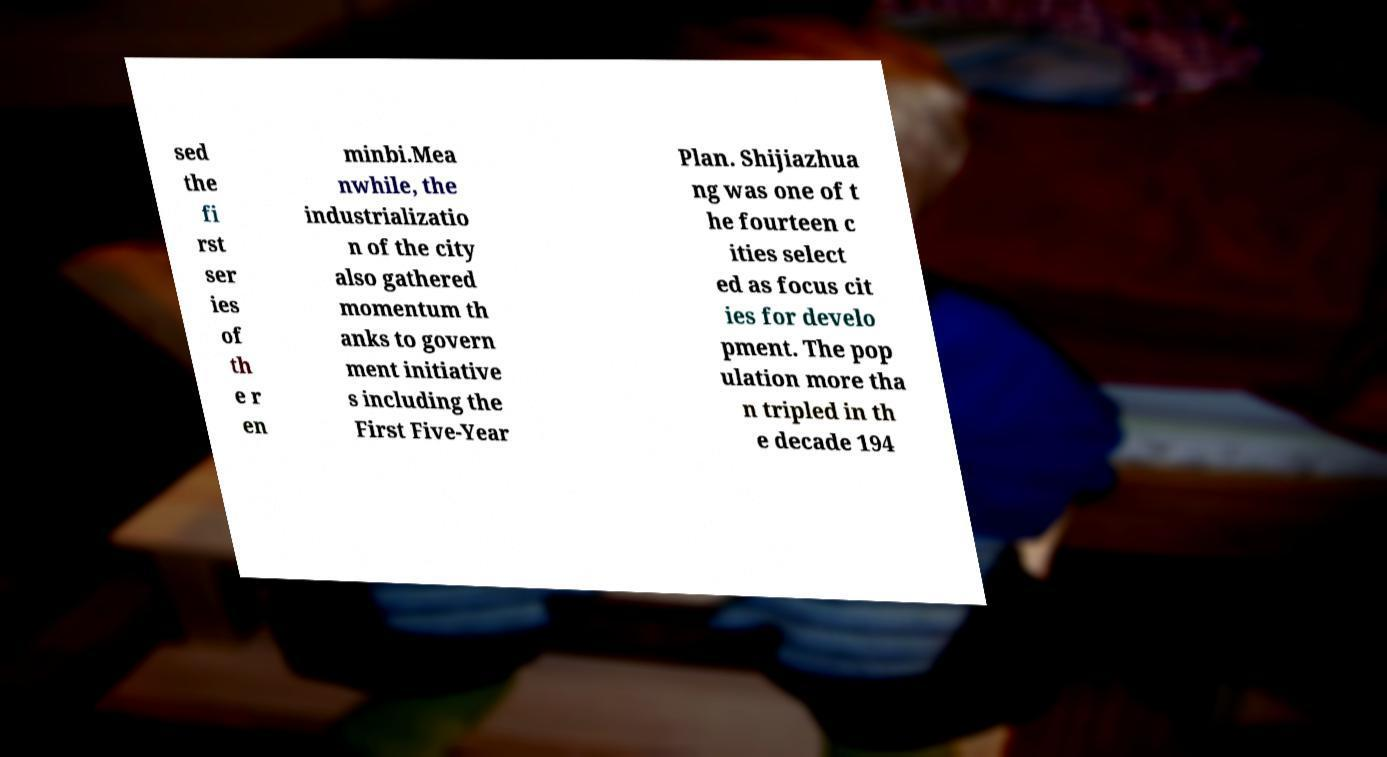Please read and relay the text visible in this image. What does it say? sed the fi rst ser ies of th e r en minbi.Mea nwhile, the industrializatio n of the city also gathered momentum th anks to govern ment initiative s including the First Five-Year Plan. Shijiazhua ng was one of t he fourteen c ities select ed as focus cit ies for develo pment. The pop ulation more tha n tripled in th e decade 194 